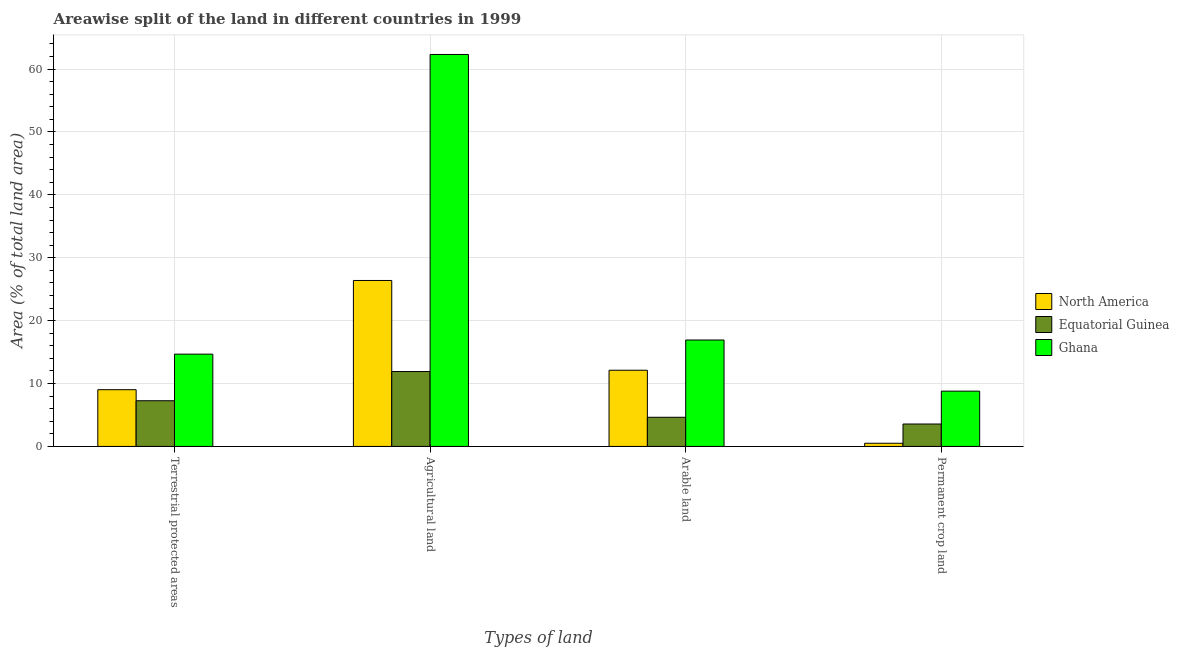How many different coloured bars are there?
Ensure brevity in your answer.  3. How many groups of bars are there?
Give a very brief answer. 4. How many bars are there on the 2nd tick from the right?
Your response must be concise. 3. What is the label of the 3rd group of bars from the left?
Keep it short and to the point. Arable land. What is the percentage of area under agricultural land in North America?
Your answer should be very brief. 26.39. Across all countries, what is the maximum percentage of area under arable land?
Offer a terse response. 16.92. Across all countries, what is the minimum percentage of area under permanent crop land?
Keep it short and to the point. 0.5. In which country was the percentage of land under terrestrial protection minimum?
Ensure brevity in your answer.  Equatorial Guinea. What is the total percentage of land under terrestrial protection in the graph?
Make the answer very short. 30.96. What is the difference between the percentage of area under agricultural land in Equatorial Guinea and that in North America?
Provide a succinct answer. -14.48. What is the difference between the percentage of area under arable land in Ghana and the percentage of land under terrestrial protection in Equatorial Guinea?
Make the answer very short. 9.66. What is the average percentage of land under terrestrial protection per country?
Your answer should be very brief. 10.32. What is the difference between the percentage of area under permanent crop land and percentage of area under arable land in Ghana?
Make the answer very short. -8.13. What is the ratio of the percentage of area under agricultural land in Equatorial Guinea to that in Ghana?
Offer a very short reply. 0.19. What is the difference between the highest and the second highest percentage of area under agricultural land?
Offer a very short reply. 35.93. What is the difference between the highest and the lowest percentage of area under arable land?
Make the answer very short. 12.29. In how many countries, is the percentage of area under permanent crop land greater than the average percentage of area under permanent crop land taken over all countries?
Your answer should be very brief. 1. Is the sum of the percentage of area under arable land in North America and Equatorial Guinea greater than the maximum percentage of land under terrestrial protection across all countries?
Your response must be concise. Yes. What does the 2nd bar from the left in Permanent crop land represents?
Make the answer very short. Equatorial Guinea. What does the 2nd bar from the right in Permanent crop land represents?
Give a very brief answer. Equatorial Guinea. Is it the case that in every country, the sum of the percentage of land under terrestrial protection and percentage of area under agricultural land is greater than the percentage of area under arable land?
Provide a short and direct response. Yes. Are all the bars in the graph horizontal?
Ensure brevity in your answer.  No. How many countries are there in the graph?
Your response must be concise. 3. Does the graph contain any zero values?
Give a very brief answer. No. Where does the legend appear in the graph?
Offer a terse response. Center right. How many legend labels are there?
Offer a terse response. 3. What is the title of the graph?
Offer a terse response. Areawise split of the land in different countries in 1999. What is the label or title of the X-axis?
Provide a succinct answer. Types of land. What is the label or title of the Y-axis?
Give a very brief answer. Area (% of total land area). What is the Area (% of total land area) of North America in Terrestrial protected areas?
Give a very brief answer. 9.02. What is the Area (% of total land area) of Equatorial Guinea in Terrestrial protected areas?
Provide a succinct answer. 7.26. What is the Area (% of total land area) of Ghana in Terrestrial protected areas?
Give a very brief answer. 14.67. What is the Area (% of total land area) of North America in Agricultural land?
Offer a very short reply. 26.39. What is the Area (% of total land area) of Equatorial Guinea in Agricultural land?
Make the answer very short. 11.91. What is the Area (% of total land area) in Ghana in Agricultural land?
Your answer should be very brief. 62.32. What is the Area (% of total land area) in North America in Arable land?
Offer a terse response. 12.11. What is the Area (% of total land area) in Equatorial Guinea in Arable land?
Ensure brevity in your answer.  4.63. What is the Area (% of total land area) in Ghana in Arable land?
Offer a terse response. 16.92. What is the Area (% of total land area) of North America in Permanent crop land?
Provide a succinct answer. 0.5. What is the Area (% of total land area) in Equatorial Guinea in Permanent crop land?
Your response must be concise. 3.57. What is the Area (% of total land area) in Ghana in Permanent crop land?
Provide a succinct answer. 8.79. Across all Types of land, what is the maximum Area (% of total land area) of North America?
Provide a succinct answer. 26.39. Across all Types of land, what is the maximum Area (% of total land area) of Equatorial Guinea?
Ensure brevity in your answer.  11.91. Across all Types of land, what is the maximum Area (% of total land area) in Ghana?
Make the answer very short. 62.32. Across all Types of land, what is the minimum Area (% of total land area) of North America?
Offer a terse response. 0.5. Across all Types of land, what is the minimum Area (% of total land area) in Equatorial Guinea?
Give a very brief answer. 3.57. Across all Types of land, what is the minimum Area (% of total land area) in Ghana?
Ensure brevity in your answer.  8.79. What is the total Area (% of total land area) of North America in the graph?
Your response must be concise. 48.03. What is the total Area (% of total land area) in Equatorial Guinea in the graph?
Offer a very short reply. 27.37. What is the total Area (% of total land area) in Ghana in the graph?
Provide a succinct answer. 102.7. What is the difference between the Area (% of total land area) in North America in Terrestrial protected areas and that in Agricultural land?
Provide a succinct answer. -17.36. What is the difference between the Area (% of total land area) of Equatorial Guinea in Terrestrial protected areas and that in Agricultural land?
Make the answer very short. -4.64. What is the difference between the Area (% of total land area) in Ghana in Terrestrial protected areas and that in Agricultural land?
Offer a very short reply. -47.65. What is the difference between the Area (% of total land area) of North America in Terrestrial protected areas and that in Arable land?
Offer a terse response. -3.09. What is the difference between the Area (% of total land area) in Equatorial Guinea in Terrestrial protected areas and that in Arable land?
Give a very brief answer. 2.63. What is the difference between the Area (% of total land area) of Ghana in Terrestrial protected areas and that in Arable land?
Your answer should be very brief. -2.25. What is the difference between the Area (% of total land area) of North America in Terrestrial protected areas and that in Permanent crop land?
Your answer should be compact. 8.52. What is the difference between the Area (% of total land area) of Equatorial Guinea in Terrestrial protected areas and that in Permanent crop land?
Provide a succinct answer. 3.7. What is the difference between the Area (% of total land area) in Ghana in Terrestrial protected areas and that in Permanent crop land?
Make the answer very short. 5.88. What is the difference between the Area (% of total land area) of North America in Agricultural land and that in Arable land?
Give a very brief answer. 14.27. What is the difference between the Area (% of total land area) of Equatorial Guinea in Agricultural land and that in Arable land?
Your answer should be very brief. 7.27. What is the difference between the Area (% of total land area) of Ghana in Agricultural land and that in Arable land?
Your response must be concise. 45.4. What is the difference between the Area (% of total land area) of North America in Agricultural land and that in Permanent crop land?
Make the answer very short. 25.88. What is the difference between the Area (% of total land area) in Equatorial Guinea in Agricultural land and that in Permanent crop land?
Keep it short and to the point. 8.34. What is the difference between the Area (% of total land area) of Ghana in Agricultural land and that in Permanent crop land?
Your response must be concise. 53.53. What is the difference between the Area (% of total land area) in North America in Arable land and that in Permanent crop land?
Your answer should be very brief. 11.61. What is the difference between the Area (% of total land area) in Equatorial Guinea in Arable land and that in Permanent crop land?
Offer a very short reply. 1.07. What is the difference between the Area (% of total land area) in Ghana in Arable land and that in Permanent crop land?
Give a very brief answer. 8.13. What is the difference between the Area (% of total land area) of North America in Terrestrial protected areas and the Area (% of total land area) of Equatorial Guinea in Agricultural land?
Offer a terse response. -2.89. What is the difference between the Area (% of total land area) of North America in Terrestrial protected areas and the Area (% of total land area) of Ghana in Agricultural land?
Keep it short and to the point. -53.3. What is the difference between the Area (% of total land area) in Equatorial Guinea in Terrestrial protected areas and the Area (% of total land area) in Ghana in Agricultural land?
Offer a terse response. -55.06. What is the difference between the Area (% of total land area) in North America in Terrestrial protected areas and the Area (% of total land area) in Equatorial Guinea in Arable land?
Keep it short and to the point. 4.39. What is the difference between the Area (% of total land area) of North America in Terrestrial protected areas and the Area (% of total land area) of Ghana in Arable land?
Your answer should be very brief. -7.9. What is the difference between the Area (% of total land area) in Equatorial Guinea in Terrestrial protected areas and the Area (% of total land area) in Ghana in Arable land?
Ensure brevity in your answer.  -9.66. What is the difference between the Area (% of total land area) in North America in Terrestrial protected areas and the Area (% of total land area) in Equatorial Guinea in Permanent crop land?
Your answer should be compact. 5.46. What is the difference between the Area (% of total land area) in North America in Terrestrial protected areas and the Area (% of total land area) in Ghana in Permanent crop land?
Ensure brevity in your answer.  0.23. What is the difference between the Area (% of total land area) in Equatorial Guinea in Terrestrial protected areas and the Area (% of total land area) in Ghana in Permanent crop land?
Your answer should be very brief. -1.53. What is the difference between the Area (% of total land area) of North America in Agricultural land and the Area (% of total land area) of Equatorial Guinea in Arable land?
Make the answer very short. 21.75. What is the difference between the Area (% of total land area) in North America in Agricultural land and the Area (% of total land area) in Ghana in Arable land?
Offer a very short reply. 9.47. What is the difference between the Area (% of total land area) in Equatorial Guinea in Agricultural land and the Area (% of total land area) in Ghana in Arable land?
Your answer should be compact. -5.01. What is the difference between the Area (% of total land area) of North America in Agricultural land and the Area (% of total land area) of Equatorial Guinea in Permanent crop land?
Keep it short and to the point. 22.82. What is the difference between the Area (% of total land area) in North America in Agricultural land and the Area (% of total land area) in Ghana in Permanent crop land?
Offer a very short reply. 17.6. What is the difference between the Area (% of total land area) in Equatorial Guinea in Agricultural land and the Area (% of total land area) in Ghana in Permanent crop land?
Ensure brevity in your answer.  3.12. What is the difference between the Area (% of total land area) of North America in Arable land and the Area (% of total land area) of Equatorial Guinea in Permanent crop land?
Offer a very short reply. 8.55. What is the difference between the Area (% of total land area) in North America in Arable land and the Area (% of total land area) in Ghana in Permanent crop land?
Ensure brevity in your answer.  3.32. What is the difference between the Area (% of total land area) of Equatorial Guinea in Arable land and the Area (% of total land area) of Ghana in Permanent crop land?
Your answer should be compact. -4.16. What is the average Area (% of total land area) of North America per Types of land?
Offer a very short reply. 12.01. What is the average Area (% of total land area) in Equatorial Guinea per Types of land?
Give a very brief answer. 6.84. What is the average Area (% of total land area) of Ghana per Types of land?
Offer a terse response. 25.67. What is the difference between the Area (% of total land area) of North America and Area (% of total land area) of Equatorial Guinea in Terrestrial protected areas?
Provide a short and direct response. 1.76. What is the difference between the Area (% of total land area) of North America and Area (% of total land area) of Ghana in Terrestrial protected areas?
Provide a short and direct response. -5.65. What is the difference between the Area (% of total land area) of Equatorial Guinea and Area (% of total land area) of Ghana in Terrestrial protected areas?
Give a very brief answer. -7.41. What is the difference between the Area (% of total land area) of North America and Area (% of total land area) of Equatorial Guinea in Agricultural land?
Your response must be concise. 14.48. What is the difference between the Area (% of total land area) of North America and Area (% of total land area) of Ghana in Agricultural land?
Make the answer very short. -35.93. What is the difference between the Area (% of total land area) of Equatorial Guinea and Area (% of total land area) of Ghana in Agricultural land?
Your answer should be very brief. -50.41. What is the difference between the Area (% of total land area) of North America and Area (% of total land area) of Equatorial Guinea in Arable land?
Keep it short and to the point. 7.48. What is the difference between the Area (% of total land area) in North America and Area (% of total land area) in Ghana in Arable land?
Offer a terse response. -4.81. What is the difference between the Area (% of total land area) of Equatorial Guinea and Area (% of total land area) of Ghana in Arable land?
Your answer should be very brief. -12.29. What is the difference between the Area (% of total land area) in North America and Area (% of total land area) in Equatorial Guinea in Permanent crop land?
Your response must be concise. -3.06. What is the difference between the Area (% of total land area) in North America and Area (% of total land area) in Ghana in Permanent crop land?
Ensure brevity in your answer.  -8.29. What is the difference between the Area (% of total land area) in Equatorial Guinea and Area (% of total land area) in Ghana in Permanent crop land?
Ensure brevity in your answer.  -5.22. What is the ratio of the Area (% of total land area) in North America in Terrestrial protected areas to that in Agricultural land?
Provide a succinct answer. 0.34. What is the ratio of the Area (% of total land area) of Equatorial Guinea in Terrestrial protected areas to that in Agricultural land?
Your answer should be compact. 0.61. What is the ratio of the Area (% of total land area) in Ghana in Terrestrial protected areas to that in Agricultural land?
Provide a succinct answer. 0.24. What is the ratio of the Area (% of total land area) of North America in Terrestrial protected areas to that in Arable land?
Your response must be concise. 0.74. What is the ratio of the Area (% of total land area) of Equatorial Guinea in Terrestrial protected areas to that in Arable land?
Make the answer very short. 1.57. What is the ratio of the Area (% of total land area) of Ghana in Terrestrial protected areas to that in Arable land?
Your answer should be compact. 0.87. What is the ratio of the Area (% of total land area) of North America in Terrestrial protected areas to that in Permanent crop land?
Ensure brevity in your answer.  17.89. What is the ratio of the Area (% of total land area) of Equatorial Guinea in Terrestrial protected areas to that in Permanent crop land?
Your answer should be very brief. 2.04. What is the ratio of the Area (% of total land area) in Ghana in Terrestrial protected areas to that in Permanent crop land?
Give a very brief answer. 1.67. What is the ratio of the Area (% of total land area) of North America in Agricultural land to that in Arable land?
Make the answer very short. 2.18. What is the ratio of the Area (% of total land area) of Equatorial Guinea in Agricultural land to that in Arable land?
Keep it short and to the point. 2.57. What is the ratio of the Area (% of total land area) of Ghana in Agricultural land to that in Arable land?
Ensure brevity in your answer.  3.68. What is the ratio of the Area (% of total land area) in North America in Agricultural land to that in Permanent crop land?
Your answer should be compact. 52.33. What is the ratio of the Area (% of total land area) in Equatorial Guinea in Agricultural land to that in Permanent crop land?
Your answer should be compact. 3.34. What is the ratio of the Area (% of total land area) of Ghana in Agricultural land to that in Permanent crop land?
Give a very brief answer. 7.09. What is the ratio of the Area (% of total land area) of North America in Arable land to that in Permanent crop land?
Your answer should be very brief. 24.02. What is the ratio of the Area (% of total land area) in Equatorial Guinea in Arable land to that in Permanent crop land?
Provide a succinct answer. 1.3. What is the ratio of the Area (% of total land area) in Ghana in Arable land to that in Permanent crop land?
Your answer should be compact. 1.93. What is the difference between the highest and the second highest Area (% of total land area) in North America?
Offer a terse response. 14.27. What is the difference between the highest and the second highest Area (% of total land area) of Equatorial Guinea?
Your response must be concise. 4.64. What is the difference between the highest and the second highest Area (% of total land area) in Ghana?
Ensure brevity in your answer.  45.4. What is the difference between the highest and the lowest Area (% of total land area) in North America?
Provide a short and direct response. 25.88. What is the difference between the highest and the lowest Area (% of total land area) of Equatorial Guinea?
Your answer should be very brief. 8.34. What is the difference between the highest and the lowest Area (% of total land area) of Ghana?
Give a very brief answer. 53.53. 